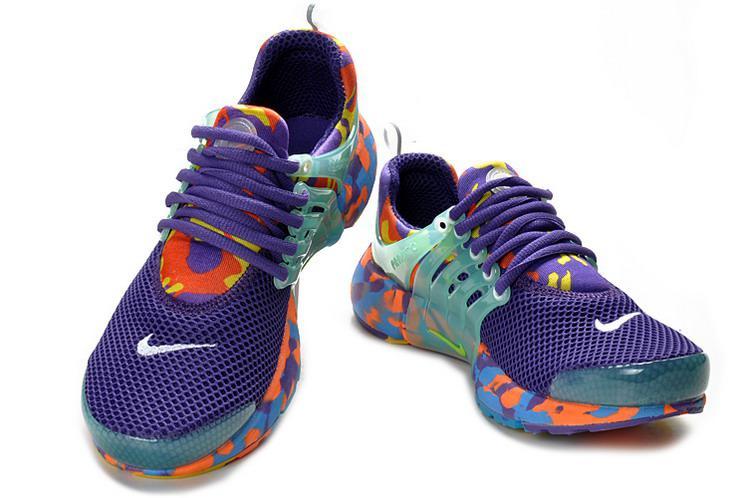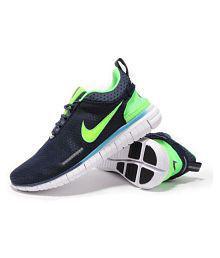The first image is the image on the left, the second image is the image on the right. Assess this claim about the two images: "One image shows a matching pair of shoe facing the right.". Correct or not? Answer yes or no. No. The first image is the image on the left, the second image is the image on the right. Analyze the images presented: Is the assertion "The shoes are flat on the ground and sitting right next to each other in the right image." valid? Answer yes or no. No. 